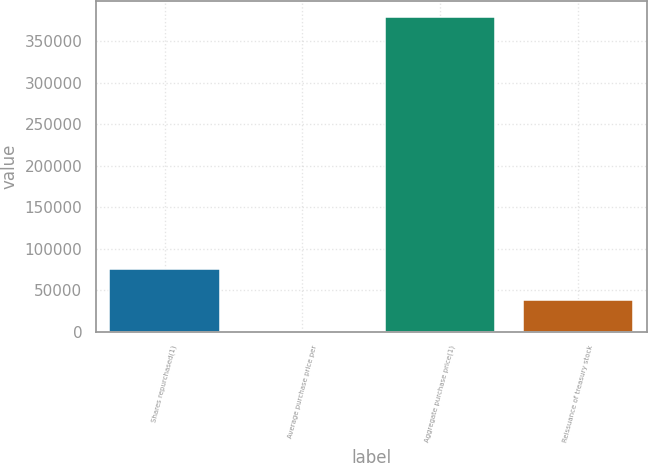<chart> <loc_0><loc_0><loc_500><loc_500><bar_chart><fcel>Shares repurchased(1)<fcel>Average purchase price per<fcel>Aggregate purchase price(1)<fcel>Reissuance of treasury stock<nl><fcel>76056.2<fcel>70.21<fcel>380000<fcel>38063.2<nl></chart> 